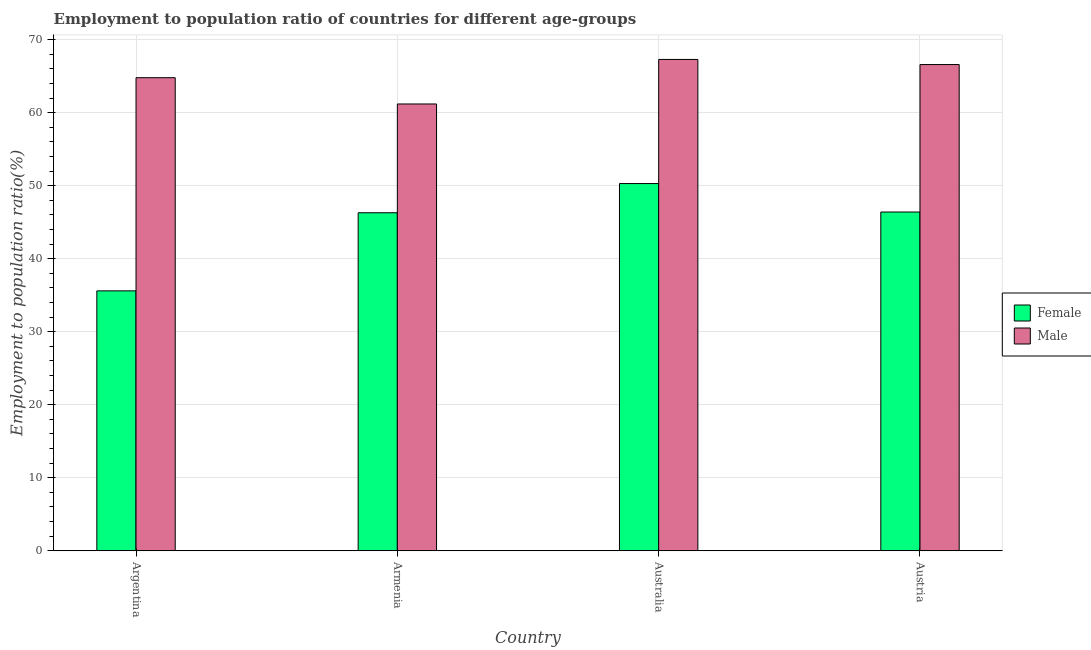How many different coloured bars are there?
Make the answer very short. 2. Are the number of bars on each tick of the X-axis equal?
Your answer should be compact. Yes. How many bars are there on the 1st tick from the left?
Your answer should be compact. 2. How many bars are there on the 2nd tick from the right?
Make the answer very short. 2. What is the employment to population ratio(male) in Armenia?
Your answer should be compact. 61.2. Across all countries, what is the maximum employment to population ratio(female)?
Your response must be concise. 50.3. Across all countries, what is the minimum employment to population ratio(female)?
Make the answer very short. 35.6. In which country was the employment to population ratio(male) minimum?
Your answer should be very brief. Armenia. What is the total employment to population ratio(male) in the graph?
Offer a very short reply. 259.9. What is the difference between the employment to population ratio(male) in Argentina and that in Armenia?
Your response must be concise. 3.6. What is the difference between the employment to population ratio(female) in Australia and the employment to population ratio(male) in Armenia?
Provide a short and direct response. -10.9. What is the average employment to population ratio(female) per country?
Your answer should be very brief. 44.65. What is the difference between the employment to population ratio(female) and employment to population ratio(male) in Argentina?
Your answer should be very brief. -29.2. What is the ratio of the employment to population ratio(female) in Argentina to that in Australia?
Your response must be concise. 0.71. Is the employment to population ratio(male) in Argentina less than that in Austria?
Give a very brief answer. Yes. Is the difference between the employment to population ratio(female) in Armenia and Australia greater than the difference between the employment to population ratio(male) in Armenia and Australia?
Ensure brevity in your answer.  Yes. What is the difference between the highest and the second highest employment to population ratio(male)?
Keep it short and to the point. 0.7. What is the difference between the highest and the lowest employment to population ratio(female)?
Your answer should be compact. 14.7. Is the sum of the employment to population ratio(male) in Australia and Austria greater than the maximum employment to population ratio(female) across all countries?
Your answer should be compact. Yes. What does the 1st bar from the right in Argentina represents?
Give a very brief answer. Male. How many bars are there?
Your response must be concise. 8. Are all the bars in the graph horizontal?
Your answer should be compact. No. How many countries are there in the graph?
Ensure brevity in your answer.  4. Are the values on the major ticks of Y-axis written in scientific E-notation?
Give a very brief answer. No. Does the graph contain grids?
Your answer should be compact. Yes. How are the legend labels stacked?
Give a very brief answer. Vertical. What is the title of the graph?
Offer a very short reply. Employment to population ratio of countries for different age-groups. Does "Chemicals" appear as one of the legend labels in the graph?
Your answer should be compact. No. What is the label or title of the X-axis?
Give a very brief answer. Country. What is the label or title of the Y-axis?
Provide a succinct answer. Employment to population ratio(%). What is the Employment to population ratio(%) of Female in Argentina?
Offer a very short reply. 35.6. What is the Employment to population ratio(%) in Male in Argentina?
Ensure brevity in your answer.  64.8. What is the Employment to population ratio(%) of Female in Armenia?
Your answer should be compact. 46.3. What is the Employment to population ratio(%) in Male in Armenia?
Your answer should be compact. 61.2. What is the Employment to population ratio(%) in Female in Australia?
Offer a very short reply. 50.3. What is the Employment to population ratio(%) in Male in Australia?
Keep it short and to the point. 67.3. What is the Employment to population ratio(%) of Female in Austria?
Your answer should be compact. 46.4. What is the Employment to population ratio(%) in Male in Austria?
Ensure brevity in your answer.  66.6. Across all countries, what is the maximum Employment to population ratio(%) of Female?
Provide a short and direct response. 50.3. Across all countries, what is the maximum Employment to population ratio(%) in Male?
Your answer should be very brief. 67.3. Across all countries, what is the minimum Employment to population ratio(%) of Female?
Ensure brevity in your answer.  35.6. Across all countries, what is the minimum Employment to population ratio(%) of Male?
Keep it short and to the point. 61.2. What is the total Employment to population ratio(%) of Female in the graph?
Your response must be concise. 178.6. What is the total Employment to population ratio(%) of Male in the graph?
Keep it short and to the point. 259.9. What is the difference between the Employment to population ratio(%) of Female in Argentina and that in Armenia?
Provide a succinct answer. -10.7. What is the difference between the Employment to population ratio(%) of Male in Argentina and that in Armenia?
Give a very brief answer. 3.6. What is the difference between the Employment to population ratio(%) in Female in Argentina and that in Australia?
Ensure brevity in your answer.  -14.7. What is the difference between the Employment to population ratio(%) in Female in Armenia and that in Australia?
Offer a terse response. -4. What is the difference between the Employment to population ratio(%) in Female in Armenia and that in Austria?
Offer a very short reply. -0.1. What is the difference between the Employment to population ratio(%) of Male in Armenia and that in Austria?
Your answer should be very brief. -5.4. What is the difference between the Employment to population ratio(%) of Female in Australia and that in Austria?
Offer a terse response. 3.9. What is the difference between the Employment to population ratio(%) of Male in Australia and that in Austria?
Offer a very short reply. 0.7. What is the difference between the Employment to population ratio(%) in Female in Argentina and the Employment to population ratio(%) in Male in Armenia?
Provide a short and direct response. -25.6. What is the difference between the Employment to population ratio(%) in Female in Argentina and the Employment to population ratio(%) in Male in Australia?
Your answer should be compact. -31.7. What is the difference between the Employment to population ratio(%) in Female in Argentina and the Employment to population ratio(%) in Male in Austria?
Your answer should be very brief. -31. What is the difference between the Employment to population ratio(%) of Female in Armenia and the Employment to population ratio(%) of Male in Austria?
Give a very brief answer. -20.3. What is the difference between the Employment to population ratio(%) of Female in Australia and the Employment to population ratio(%) of Male in Austria?
Your answer should be very brief. -16.3. What is the average Employment to population ratio(%) of Female per country?
Your answer should be very brief. 44.65. What is the average Employment to population ratio(%) of Male per country?
Your response must be concise. 64.97. What is the difference between the Employment to population ratio(%) of Female and Employment to population ratio(%) of Male in Argentina?
Your answer should be very brief. -29.2. What is the difference between the Employment to population ratio(%) of Female and Employment to population ratio(%) of Male in Armenia?
Your answer should be compact. -14.9. What is the difference between the Employment to population ratio(%) in Female and Employment to population ratio(%) in Male in Australia?
Your answer should be very brief. -17. What is the difference between the Employment to population ratio(%) in Female and Employment to population ratio(%) in Male in Austria?
Your response must be concise. -20.2. What is the ratio of the Employment to population ratio(%) in Female in Argentina to that in Armenia?
Ensure brevity in your answer.  0.77. What is the ratio of the Employment to population ratio(%) in Male in Argentina to that in Armenia?
Ensure brevity in your answer.  1.06. What is the ratio of the Employment to population ratio(%) of Female in Argentina to that in Australia?
Make the answer very short. 0.71. What is the ratio of the Employment to population ratio(%) of Male in Argentina to that in Australia?
Provide a succinct answer. 0.96. What is the ratio of the Employment to population ratio(%) in Female in Argentina to that in Austria?
Offer a terse response. 0.77. What is the ratio of the Employment to population ratio(%) of Male in Argentina to that in Austria?
Your answer should be very brief. 0.97. What is the ratio of the Employment to population ratio(%) of Female in Armenia to that in Australia?
Offer a terse response. 0.92. What is the ratio of the Employment to population ratio(%) of Male in Armenia to that in Australia?
Offer a very short reply. 0.91. What is the ratio of the Employment to population ratio(%) of Male in Armenia to that in Austria?
Your response must be concise. 0.92. What is the ratio of the Employment to population ratio(%) of Female in Australia to that in Austria?
Make the answer very short. 1.08. What is the ratio of the Employment to population ratio(%) of Male in Australia to that in Austria?
Your answer should be very brief. 1.01. What is the difference between the highest and the second highest Employment to population ratio(%) of Female?
Offer a very short reply. 3.9. 